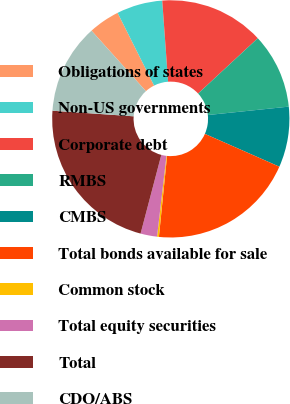Convert chart to OTSL. <chart><loc_0><loc_0><loc_500><loc_500><pie_chart><fcel>Obligations of states<fcel>Non-US governments<fcel>Corporate debt<fcel>RMBS<fcel>CMBS<fcel>Total bonds available for sale<fcel>Common stock<fcel>Total equity securities<fcel>Total<fcel>CDO/ABS<nl><fcel>4.25%<fcel>6.25%<fcel>14.25%<fcel>10.25%<fcel>8.25%<fcel>19.99%<fcel>0.25%<fcel>2.25%<fcel>21.99%<fcel>12.25%<nl></chart> 